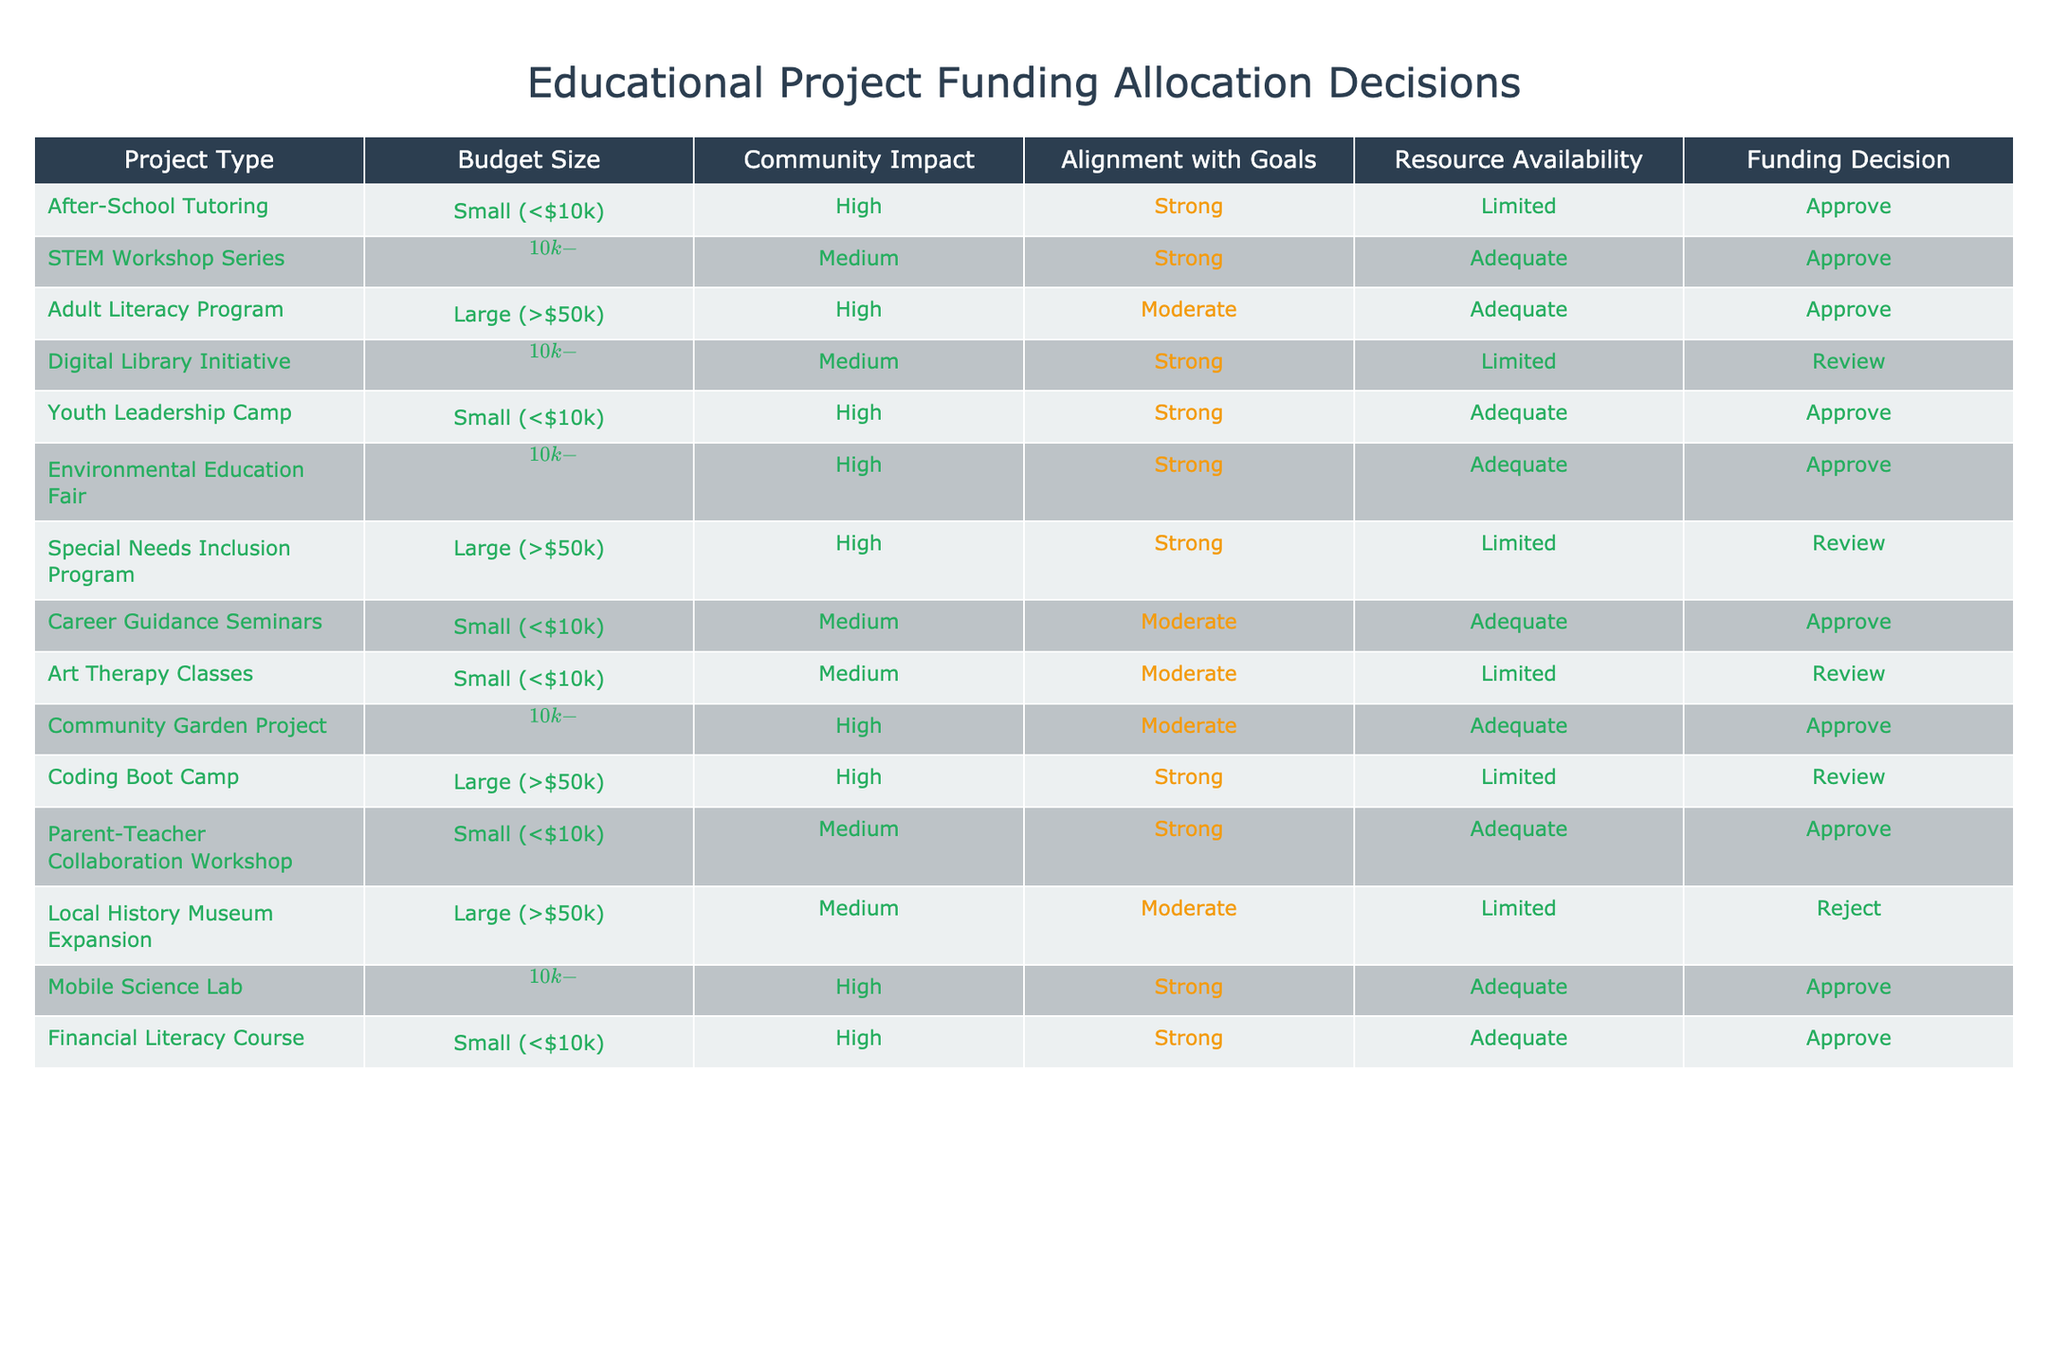What type of project received the highest number of approvals? By inspecting the "Funding Decision" column, we see that the most common decision is "Approve". Reviewing the projects listed under this decision, we find that the type of project with the highest count is "Small (<$10k)" projects, specifically the After-School Tutoring, Youth Leadership Camp, Career Guidance Seminars, and Financial Literacy Course.
Answer: Small (<$10k) How many projects were reviewed due to limited resource availability? We can look at the "Resource Availability" column and find all instances labeled as "Limited". Checking through the list, I see that the Digital Library Initiative, Special Needs Inclusion Program, Coding Boot Camp, and After-School Tutoring each fall under this category. This sums up to 4 projects that required a review.
Answer: 4 Is it true that all projects aligned strongly with the organization's goals were approved? Analyzing the "Alignment with Goals" column, we can pinpoint projects marked as "Strong" and check their corresponding "Funding Decision". The After-School Tutoring, STEM Workshop Series, Youth Leadership Camp, Environmental Education Fair, and Parent-Teacher Collaboration Workshop all align strongly and were approved. However, the Digital Library Initiative and the Special Needs Inclusion Program were labeled "Review" even though they had strong alignment, revealing they weren't all approved. Thus, the statement is false.
Answer: No What is the average budget size of the projects that were approved? To calculate the average, we filter by the "Funding Decision" column for "Approve" and list their respective budget sizes: Small (<$10k), Medium ($10k-$50k), and Large (>$50k). Assigning values (Small=5, Medium=30, Large=75), we find 6 approved projects fall into small size (5), 6 into medium size (30), and none for large (75). Thus, (6*5 + 6*30)/12 = (30 + 180)/12 = 210/12 = 17.5. The average budget size is therefore approximately 17.5.
Answer: 17.5 Which project type had mixed resource availability with funding outcomes? By evaluating the "Resource Availability" combined with "Funding Decision", we can locate projects where resource availability is both "Adequate" and "Limited". The Digital Library Initiative and the Special Needs Inclusion Program stood out; the former had limited resources and was reviewed while the latter had sufficient resources but was still reviewed.
Answer: Digital Library Initiative and Special Needs Inclusion Program 